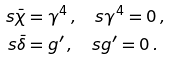Convert formula to latex. <formula><loc_0><loc_0><loc_500><loc_500>s \bar { \chi } & = \gamma ^ { 4 } \, , \quad s \gamma ^ { 4 } = 0 \, , \\ s \bar { \delta } & = g ^ { \prime } \, , \quad s g ^ { \prime } = 0 \, .</formula> 